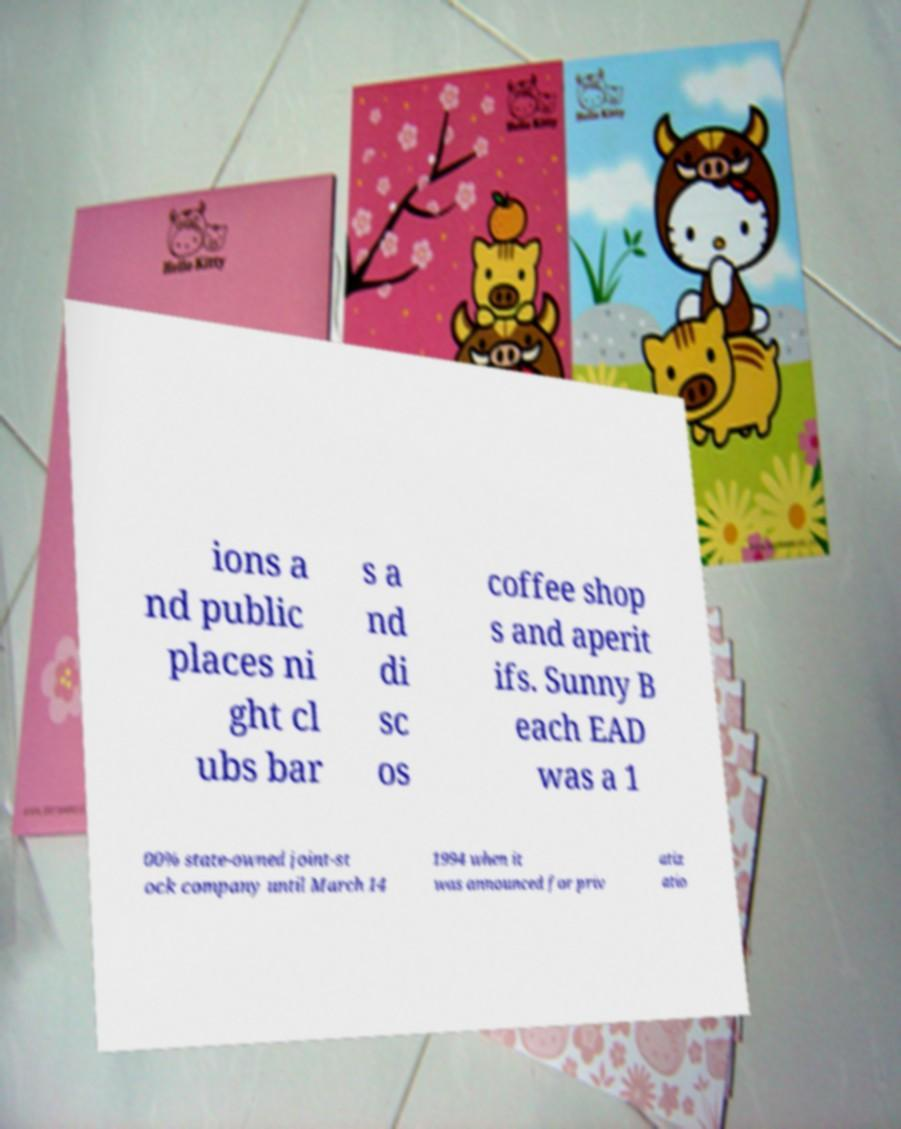Could you assist in decoding the text presented in this image and type it out clearly? ions a nd public places ni ght cl ubs bar s a nd di sc os coffee shop s and aperit ifs. Sunny B each EAD was a 1 00% state-owned joint-st ock company until March 14 1994 when it was announced for priv atiz atio 